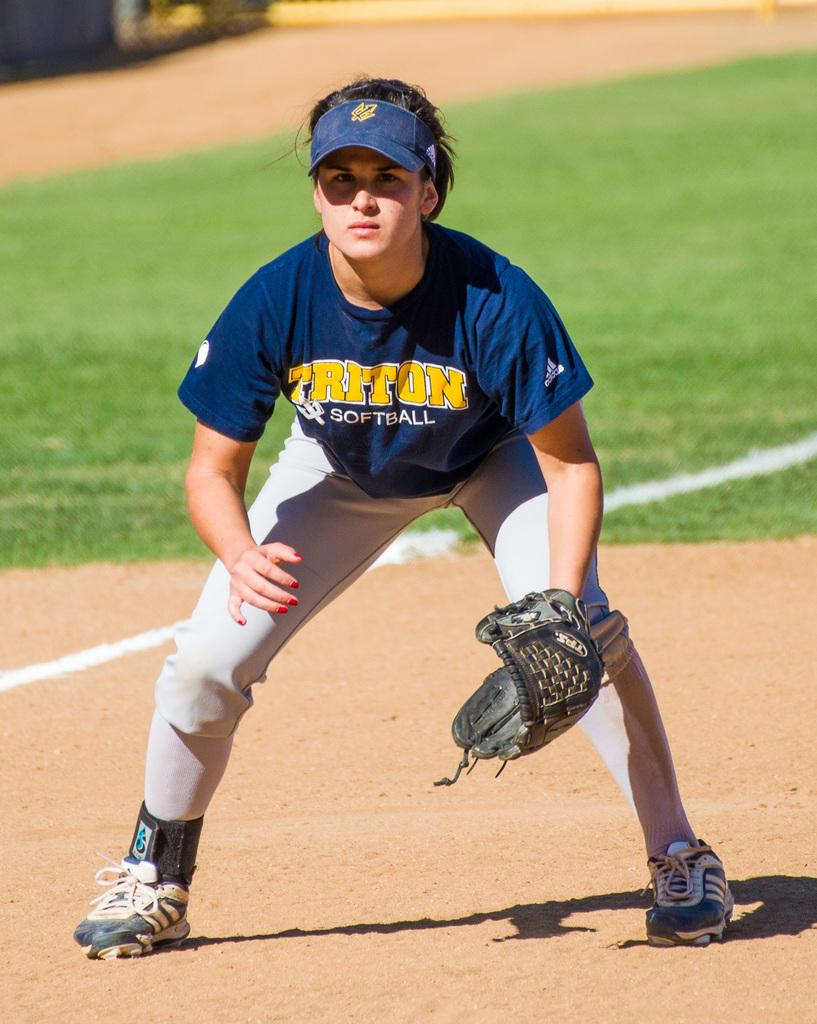<image>
Share a concise interpretation of the image provided. A person wearing a Triton Softball jersey squats in the field. 